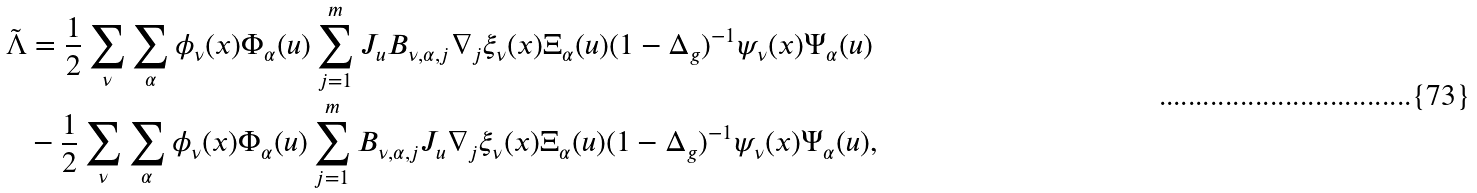Convert formula to latex. <formula><loc_0><loc_0><loc_500><loc_500>\tilde { \Lambda } & = \frac { 1 } { 2 } \sum _ { \nu } \sum _ { \alpha } \phi _ { \nu } ( x ) \Phi _ { \alpha } ( u ) \sum _ { j = 1 } ^ { m } J _ { u } B _ { \nu , \alpha , j } \nabla _ { j } \xi _ { \nu } ( x ) \Xi _ { \alpha } ( u ) ( 1 - \Delta _ { g } ) ^ { - 1 } \psi _ { \nu } ( x ) \Psi _ { \alpha } ( u ) \\ & - \frac { 1 } { 2 } \sum _ { \nu } \sum _ { \alpha } \phi _ { \nu } ( x ) \Phi _ { \alpha } ( u ) \sum _ { j = 1 } ^ { m } B _ { \nu , \alpha , j } J _ { u } \nabla _ { j } \xi _ { \nu } ( x ) \Xi _ { \alpha } ( u ) ( 1 - \Delta _ { g } ) ^ { - 1 } \psi _ { \nu } ( x ) \Psi _ { \alpha } ( u ) ,</formula> 